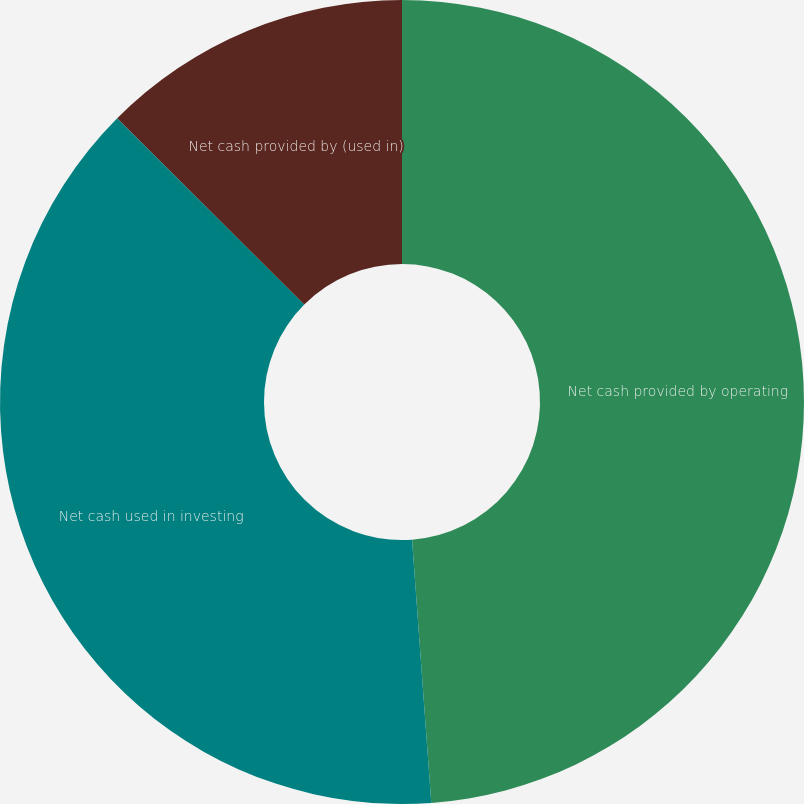Convert chart. <chart><loc_0><loc_0><loc_500><loc_500><pie_chart><fcel>Net cash provided by operating<fcel>Net cash used in investing<fcel>Net cash provided by (used in)<nl><fcel>48.84%<fcel>38.63%<fcel>12.53%<nl></chart> 